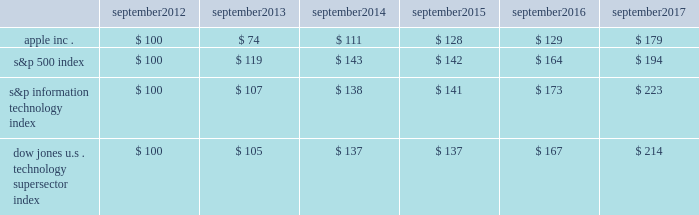Apple inc .
| 2017 form 10-k | 20 company stock performance the following graph shows a comparison of cumulative total shareholder return , calculated on a dividend reinvested basis , for the company , the s&p 500 index , the s&p information technology index and the dow jones u.s .
Technology supersector index for the five years ended september 30 , 2017 .
The graph assumes $ 100 was invested in each of the company 2019s common stock , the s&p 500 index , the s&p information technology index and the dow jones u.s .
Technology supersector index as of the market close on september 28 , 2012 .
Note that historic stock price performance is not necessarily indicative of future stock price performance .
* $ 100 invested on 9/28/12 in stock or index , including reinvestment of dividends .
Data points are the last day of each fiscal year for the company 2019s common stock and september 30th for indexes .
Copyright a9 2017 s&p , a division of mcgraw hill financial .
All rights reserved .
Copyright a9 2017 dow jones & co .
All rights reserved .
September september september september september september .

What was the change in the apple stock return between 2016 and 2017? 
Computations: (179 - 129)
Answer: 50.0. 